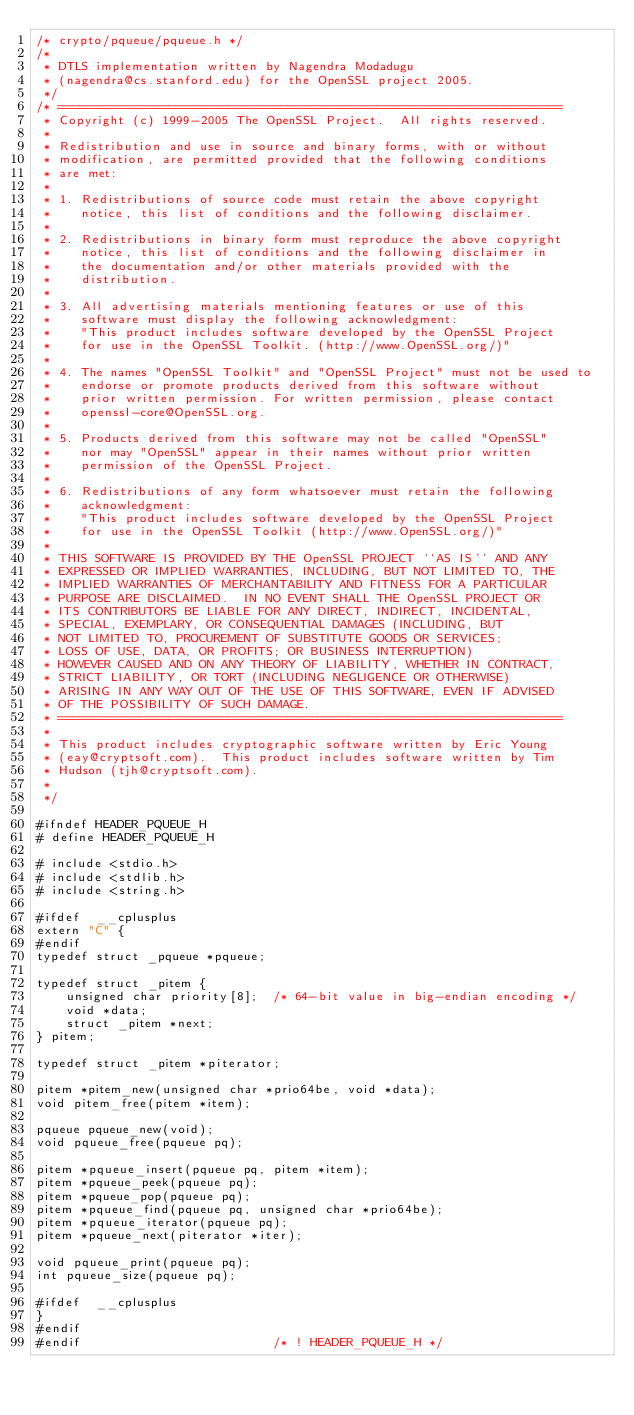Convert code to text. <code><loc_0><loc_0><loc_500><loc_500><_C_>/* crypto/pqueue/pqueue.h */
/*
 * DTLS implementation written by Nagendra Modadugu
 * (nagendra@cs.stanford.edu) for the OpenSSL project 2005.
 */
/* ====================================================================
 * Copyright (c) 1999-2005 The OpenSSL Project.  All rights reserved.
 *
 * Redistribution and use in source and binary forms, with or without
 * modification, are permitted provided that the following conditions
 * are met:
 *
 * 1. Redistributions of source code must retain the above copyright
 *    notice, this list of conditions and the following disclaimer.
 *
 * 2. Redistributions in binary form must reproduce the above copyright
 *    notice, this list of conditions and the following disclaimer in
 *    the documentation and/or other materials provided with the
 *    distribution.
 *
 * 3. All advertising materials mentioning features or use of this
 *    software must display the following acknowledgment:
 *    "This product includes software developed by the OpenSSL Project
 *    for use in the OpenSSL Toolkit. (http://www.OpenSSL.org/)"
 *
 * 4. The names "OpenSSL Toolkit" and "OpenSSL Project" must not be used to
 *    endorse or promote products derived from this software without
 *    prior written permission. For written permission, please contact
 *    openssl-core@OpenSSL.org.
 *
 * 5. Products derived from this software may not be called "OpenSSL"
 *    nor may "OpenSSL" appear in their names without prior written
 *    permission of the OpenSSL Project.
 *
 * 6. Redistributions of any form whatsoever must retain the following
 *    acknowledgment:
 *    "This product includes software developed by the OpenSSL Project
 *    for use in the OpenSSL Toolkit (http://www.OpenSSL.org/)"
 *
 * THIS SOFTWARE IS PROVIDED BY THE OpenSSL PROJECT ``AS IS'' AND ANY
 * EXPRESSED OR IMPLIED WARRANTIES, INCLUDING, BUT NOT LIMITED TO, THE
 * IMPLIED WARRANTIES OF MERCHANTABILITY AND FITNESS FOR A PARTICULAR
 * PURPOSE ARE DISCLAIMED.  IN NO EVENT SHALL THE OpenSSL PROJECT OR
 * ITS CONTRIBUTORS BE LIABLE FOR ANY DIRECT, INDIRECT, INCIDENTAL,
 * SPECIAL, EXEMPLARY, OR CONSEQUENTIAL DAMAGES (INCLUDING, BUT
 * NOT LIMITED TO, PROCUREMENT OF SUBSTITUTE GOODS OR SERVICES;
 * LOSS OF USE, DATA, OR PROFITS; OR BUSINESS INTERRUPTION)
 * HOWEVER CAUSED AND ON ANY THEORY OF LIABILITY, WHETHER IN CONTRACT,
 * STRICT LIABILITY, OR TORT (INCLUDING NEGLIGENCE OR OTHERWISE)
 * ARISING IN ANY WAY OUT OF THE USE OF THIS SOFTWARE, EVEN IF ADVISED
 * OF THE POSSIBILITY OF SUCH DAMAGE.
 * ====================================================================
 *
 * This product includes cryptographic software written by Eric Young
 * (eay@cryptsoft.com).  This product includes software written by Tim
 * Hudson (tjh@cryptsoft.com).
 *
 */

#ifndef HEADER_PQUEUE_H
# define HEADER_PQUEUE_H

# include <stdio.h>
# include <stdlib.h>
# include <string.h>

#ifdef  __cplusplus
extern "C" {
#endif
typedef struct _pqueue *pqueue;

typedef struct _pitem {
    unsigned char priority[8];  /* 64-bit value in big-endian encoding */
    void *data;
    struct _pitem *next;
} pitem;

typedef struct _pitem *piterator;

pitem *pitem_new(unsigned char *prio64be, void *data);
void pitem_free(pitem *item);

pqueue pqueue_new(void);
void pqueue_free(pqueue pq);

pitem *pqueue_insert(pqueue pq, pitem *item);
pitem *pqueue_peek(pqueue pq);
pitem *pqueue_pop(pqueue pq);
pitem *pqueue_find(pqueue pq, unsigned char *prio64be);
pitem *pqueue_iterator(pqueue pq);
pitem *pqueue_next(piterator *iter);

void pqueue_print(pqueue pq);
int pqueue_size(pqueue pq);

#ifdef  __cplusplus
}
#endif
#endif                          /* ! HEADER_PQUEUE_H */
</code> 